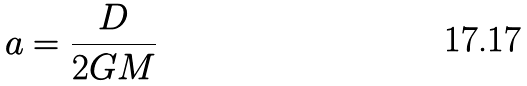<formula> <loc_0><loc_0><loc_500><loc_500>a = \frac { D } { 2 G M }</formula> 